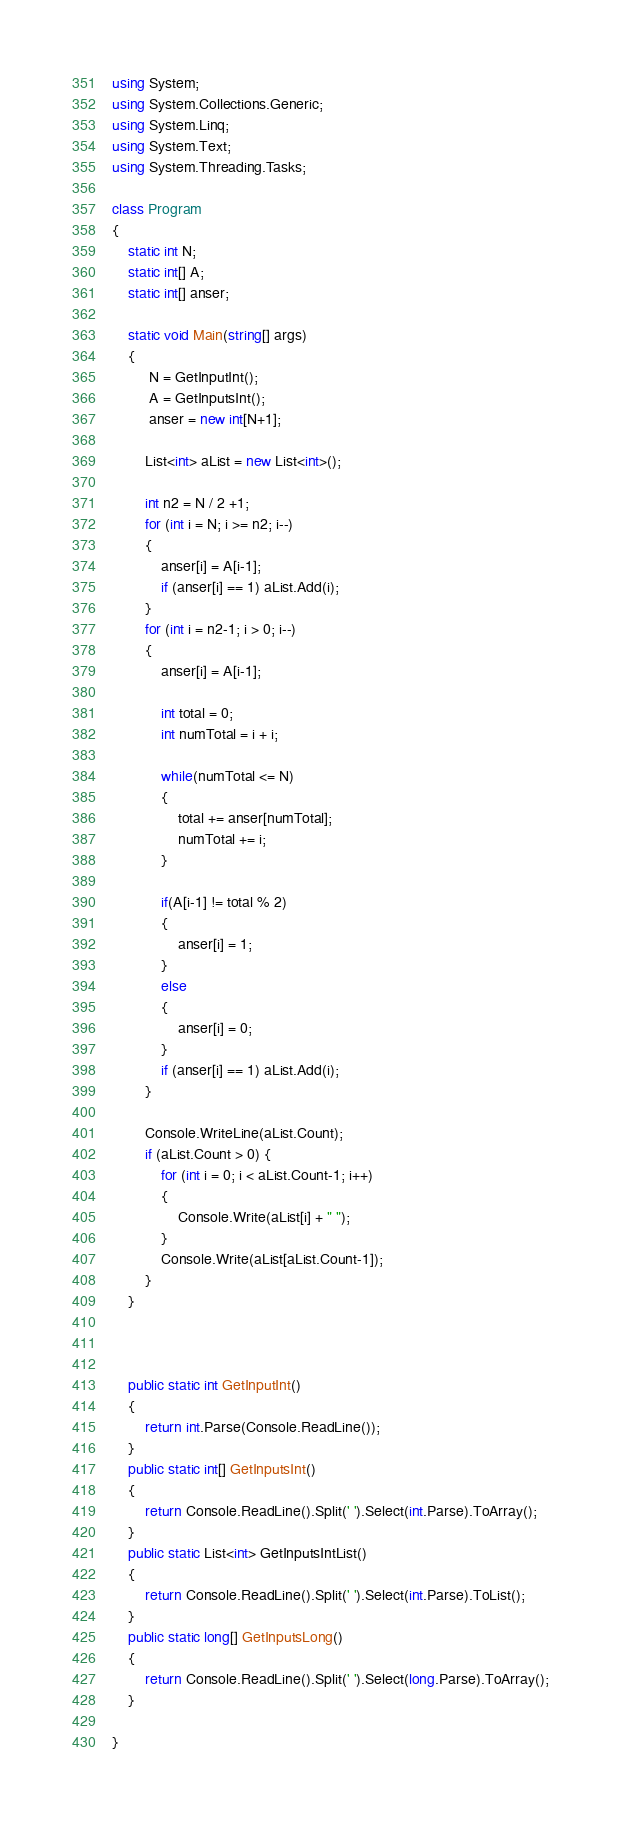Convert code to text. <code><loc_0><loc_0><loc_500><loc_500><_C#_>using System;
using System.Collections.Generic;
using System.Linq;
using System.Text;
using System.Threading.Tasks;

class Program
{
    static int N;
    static int[] A;
    static int[] anser;

    static void Main(string[] args)
    {
         N = GetInputInt();
         A = GetInputsInt();
         anser = new int[N+1];

        List<int> aList = new List<int>();

        int n2 = N / 2 +1;
        for (int i = N; i >= n2; i--)
        {
            anser[i] = A[i-1];
            if (anser[i] == 1) aList.Add(i);
        }
        for (int i = n2-1; i > 0; i--)
        {
            anser[i] = A[i-1];

            int total = 0;
            int numTotal = i + i;

            while(numTotal <= N)
            {
                total += anser[numTotal];
                numTotal += i;
            }
            
            if(A[i-1] != total % 2)
            {
                anser[i] = 1;
            }
            else
            {
                anser[i] = 0;
            }
            if (anser[i] == 1) aList.Add(i);
        }

        Console.WriteLine(aList.Count);
        if (aList.Count > 0) {
            for (int i = 0; i < aList.Count-1; i++)
            {
                Console.Write(aList[i] + " ");
            }
            Console.Write(aList[aList.Count-1]);
        }
    }

    

    public static int GetInputInt()
    {
        return int.Parse(Console.ReadLine());
    }
    public static int[] GetInputsInt()
    {
        return Console.ReadLine().Split(' ').Select(int.Parse).ToArray();
    }
    public static List<int> GetInputsIntList()
    {
        return Console.ReadLine().Split(' ').Select(int.Parse).ToList();
    }
    public static long[] GetInputsLong()
    {
        return Console.ReadLine().Split(' ').Select(long.Parse).ToArray();
    }

}
</code> 